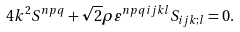<formula> <loc_0><loc_0><loc_500><loc_500>4 k ^ { 2 } S ^ { n p q } + \sqrt { 2 } \rho \varepsilon ^ { n p q i j k l } S _ { i j k ; l } = 0 .</formula> 